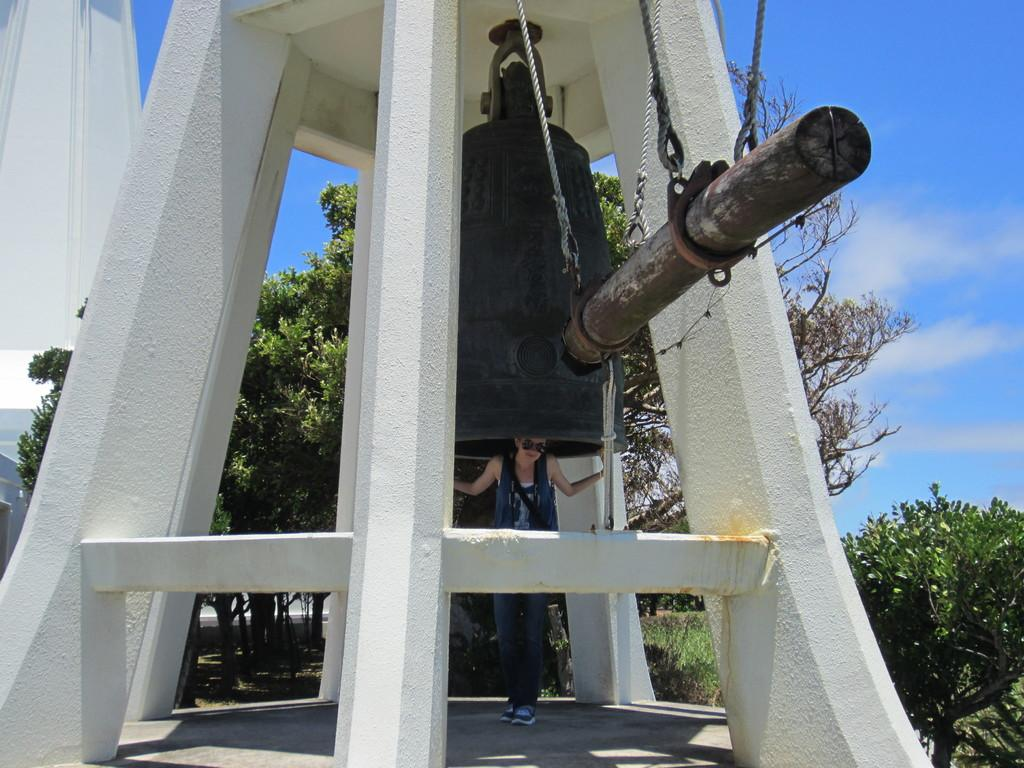Who is the main subject in the image? There is a bellperson in the center of the image. What object is the bellperson holding? The bellperson is holding a stick in the center of the image. What can be seen in the background of the image? There is a building, trees, plants, and the sky visible in the background of the image. What is the condition of the sky in the image? The sky is visible in the background of the image, and there are clouds present. What type of meal is being prepared by the bellperson in the image? There is no meal being prepared in the image; the bellperson is holding a stick. What is the bellperson hoping to achieve with the stick in the image? The image does not provide any information about the bellperson's hopes or intentions, so it cannot be determined from the image. 